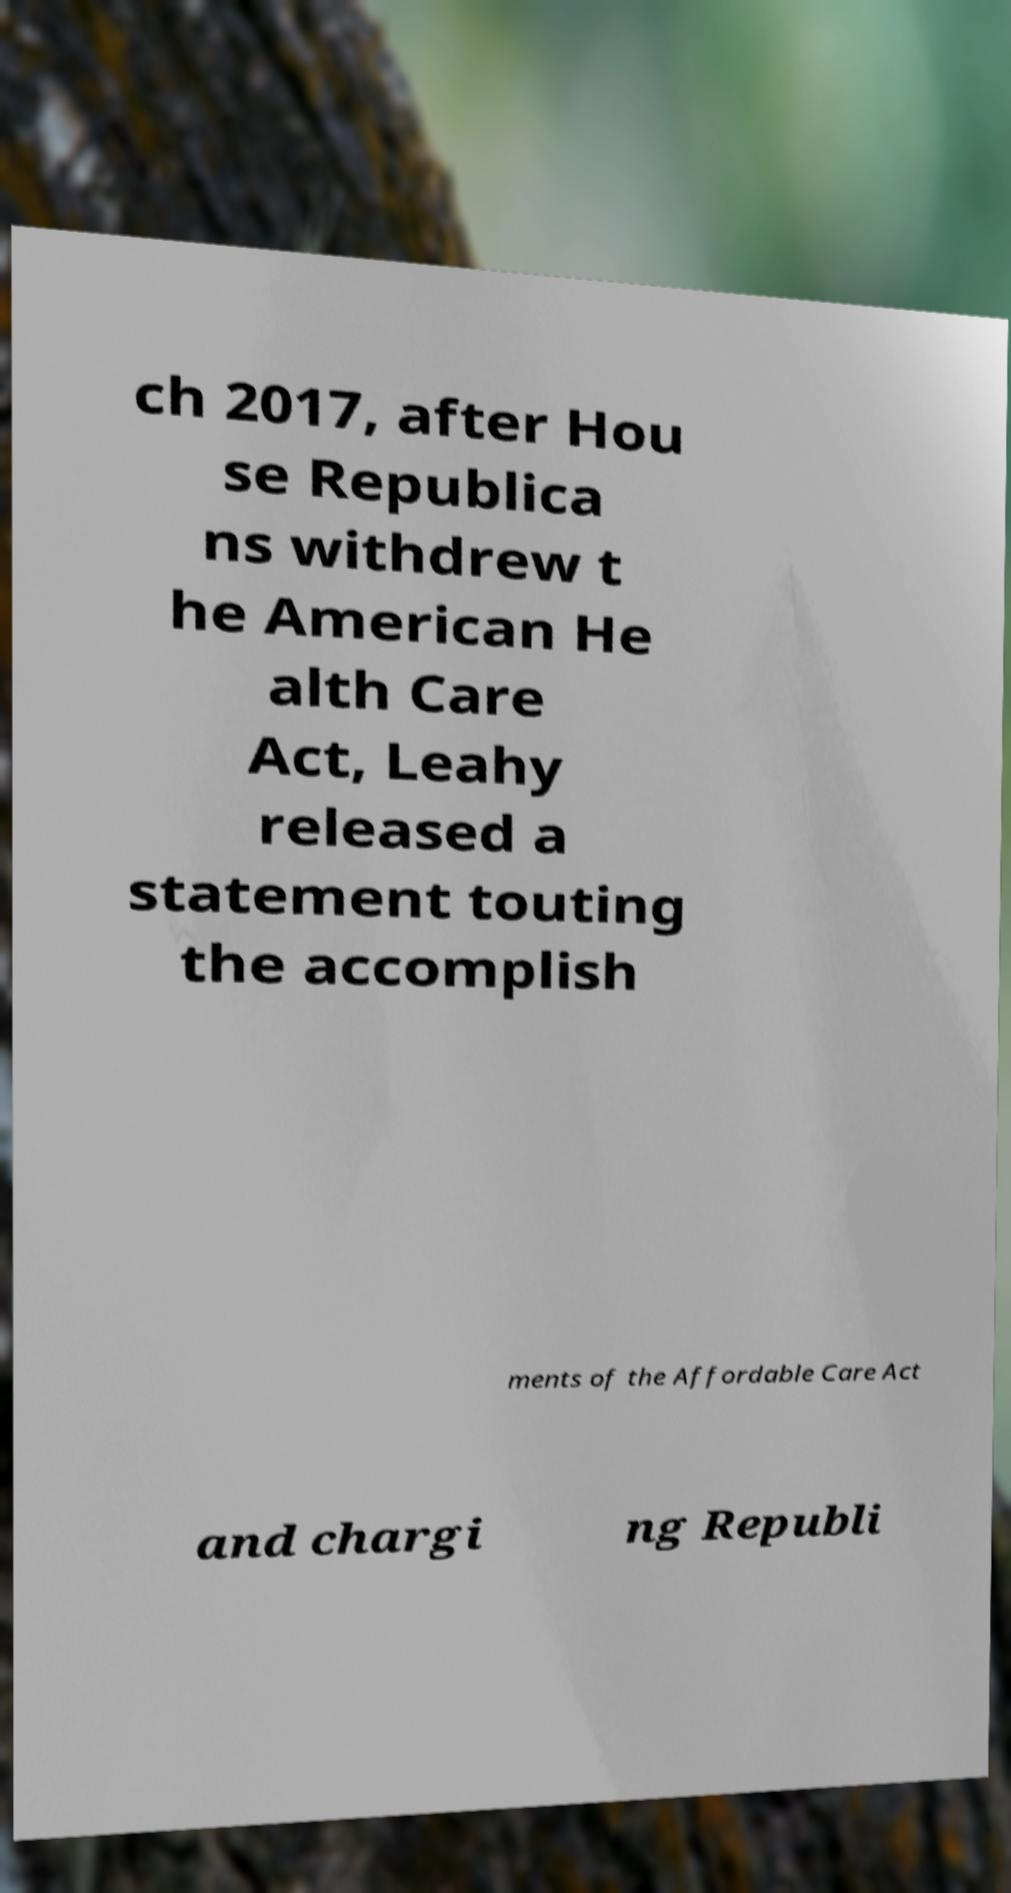Could you assist in decoding the text presented in this image and type it out clearly? ch 2017, after Hou se Republica ns withdrew t he American He alth Care Act, Leahy released a statement touting the accomplish ments of the Affordable Care Act and chargi ng Republi 